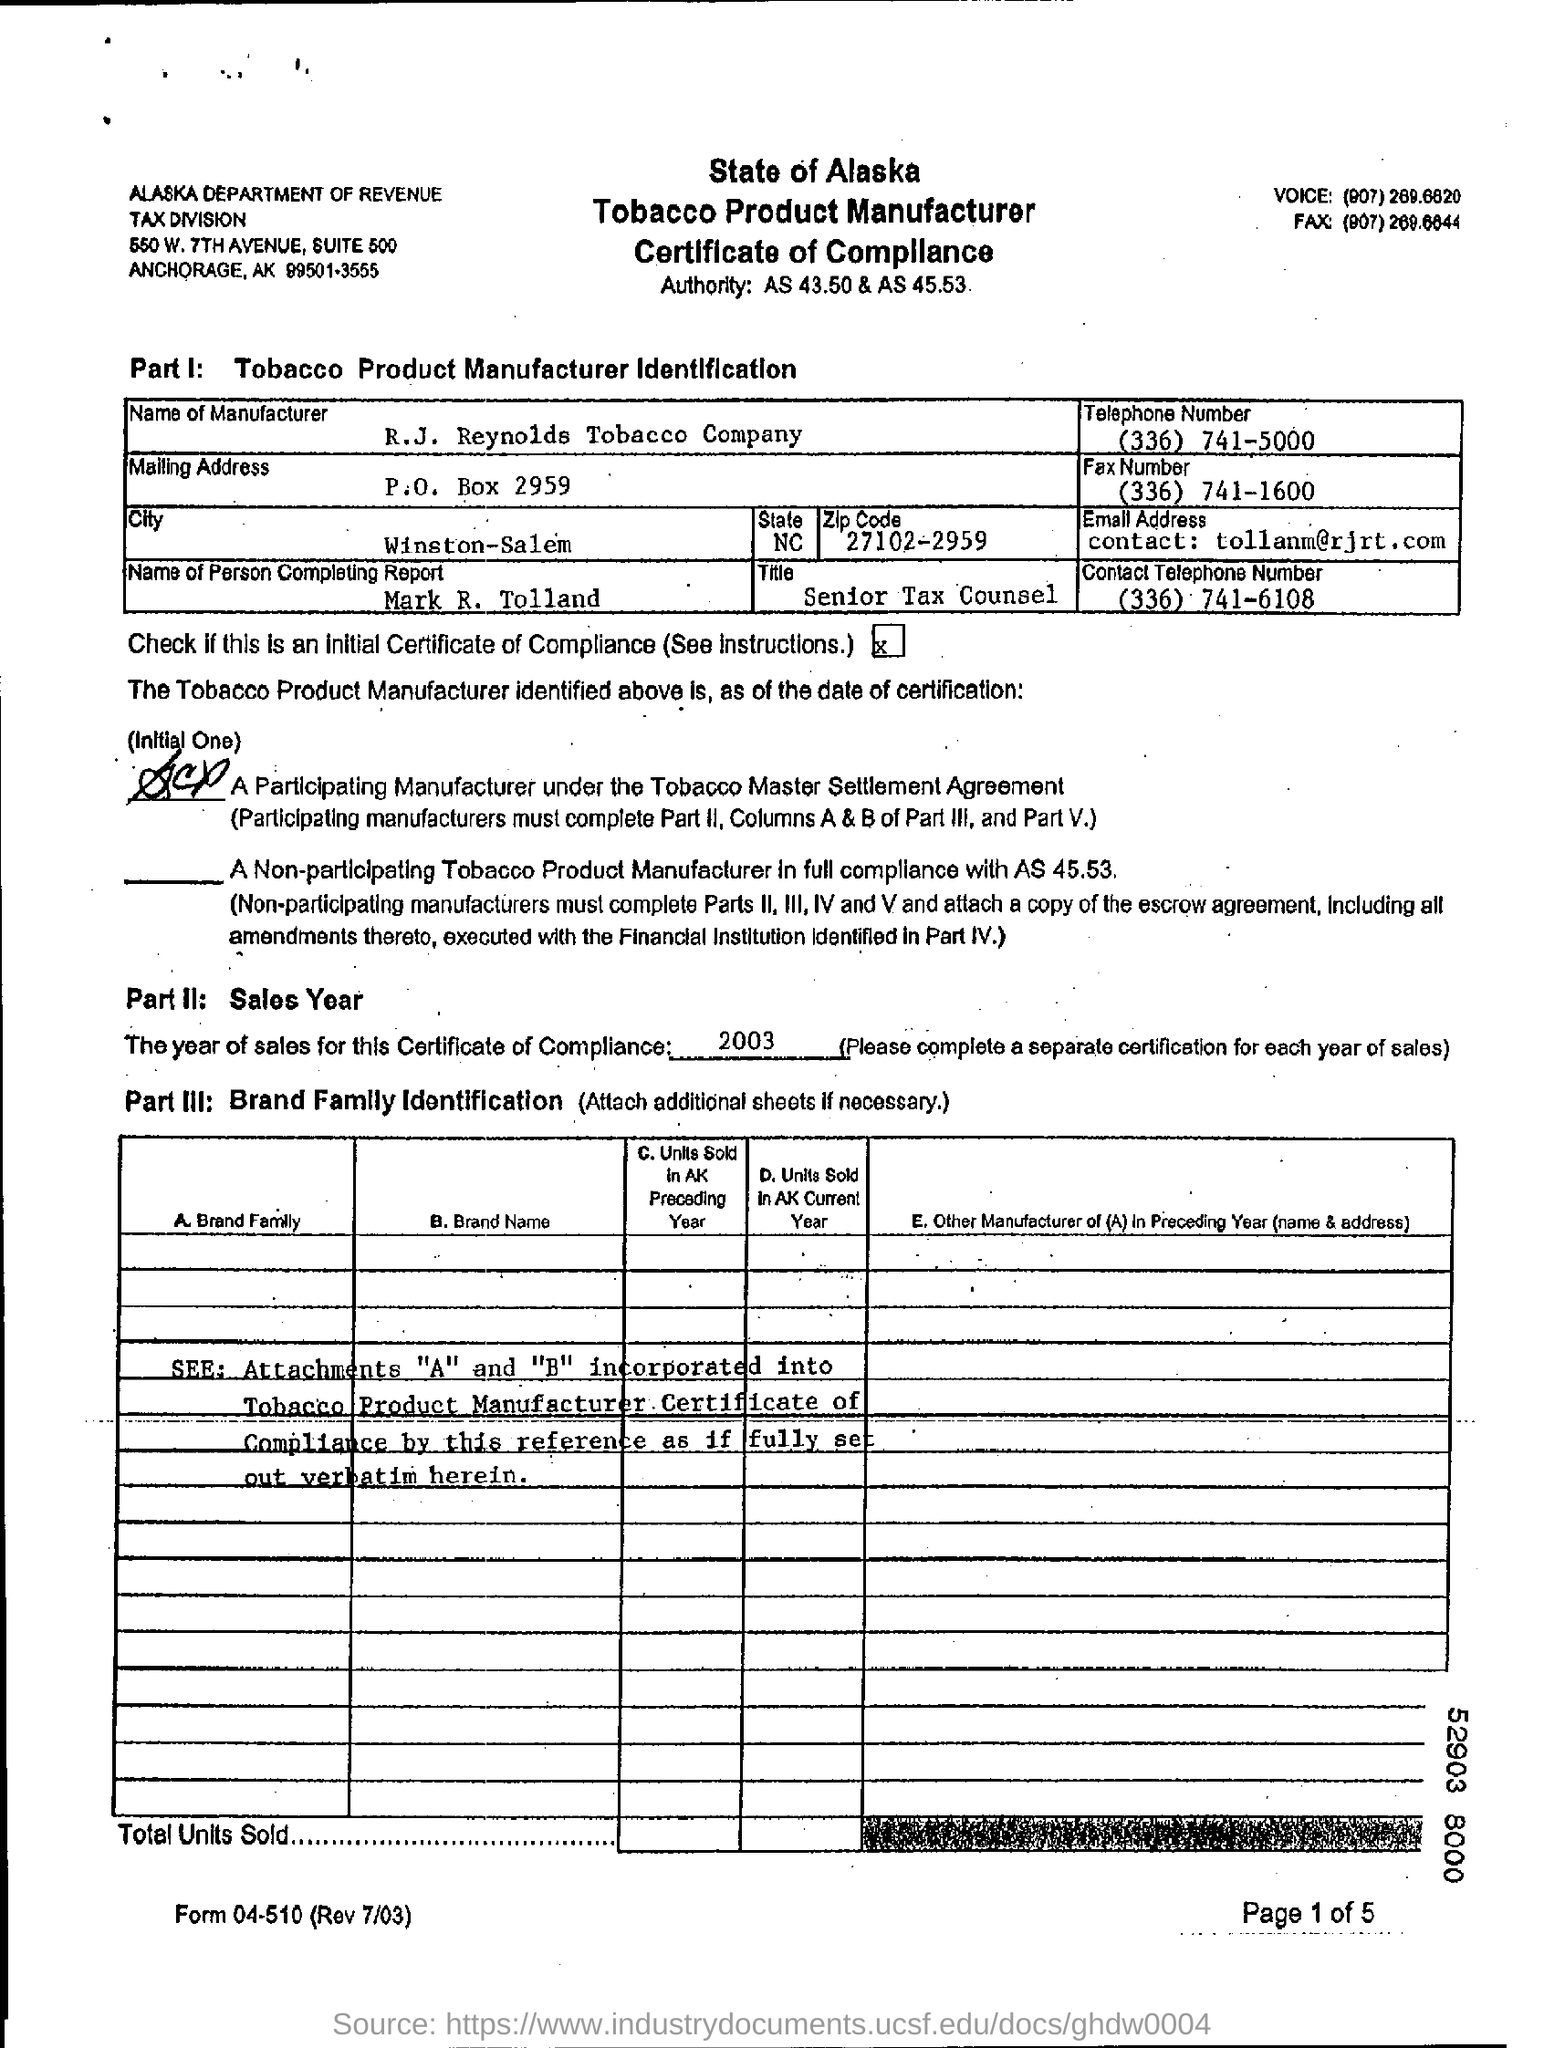Identify some key points in this picture. A P.O. Box Number is a physical address used for receiving mail and packages, typically used by individuals or businesses who prefer to keep their home or business address private. The manufacturer of the product is R.J. Reynolds Tobacco Company. The year of the sales for this certificate of compliance is 2003. 